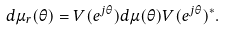<formula> <loc_0><loc_0><loc_500><loc_500>d \mu _ { r } ( \theta ) = V ( e ^ { j \theta } ) d \mu ( \theta ) V ( e ^ { j \theta } ) ^ { * } .</formula> 